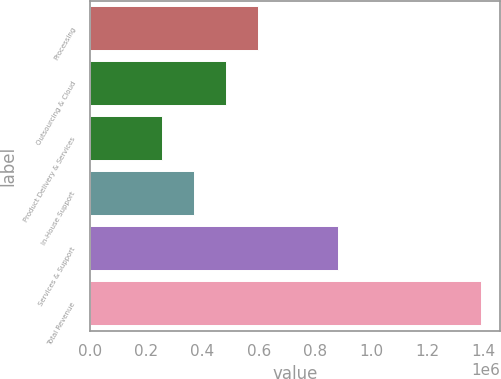Convert chart. <chart><loc_0><loc_0><loc_500><loc_500><bar_chart><fcel>Processing<fcel>Outsourcing & Cloud<fcel>Product Delivery & Services<fcel>In-House Support<fcel>Services & Support<fcel>Total Revenue<nl><fcel>596243<fcel>483093<fcel>256794<fcel>369944<fcel>881735<fcel>1.38829e+06<nl></chart> 